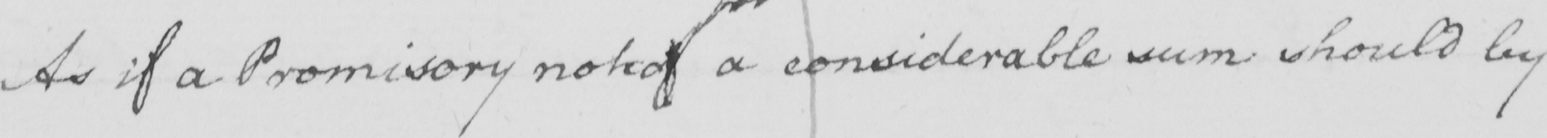Can you tell me what this handwritten text says? As if a Promisory note of a considerable sum should by 